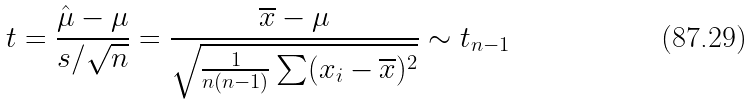<formula> <loc_0><loc_0><loc_500><loc_500>t = { \frac { { \hat { \mu } } - \mu } { s / { \sqrt { n } } } } = { \frac { { \overline { x } } - \mu } { \sqrt { { \frac { 1 } { n ( n - 1 ) } } \sum ( x _ { i } - { \overline { x } } ) ^ { 2 } } } } \sim t _ { n - 1 }</formula> 